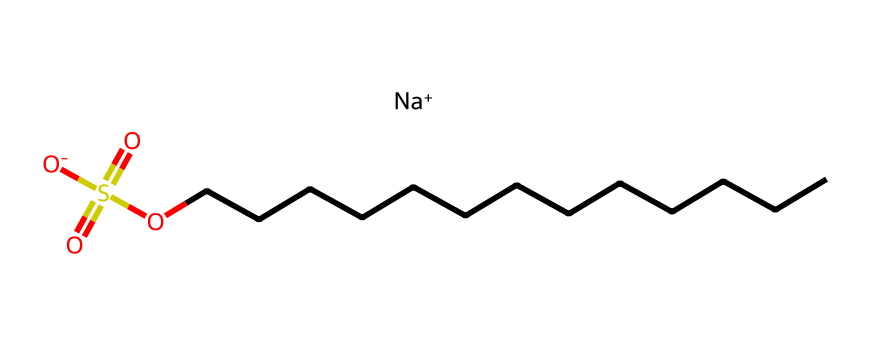How many carbon atoms are in sodium dodecyl sulfate? The chemical structure contains a long hydrocarbon chain indicated by the sequence of "C" in the SMILES representation. Counting the "C" characters, there are 12 carbon atoms in the dodecyl chain.
Answer: 12 What is the primary functional group present in sodium dodecyl sulfate? The chemical includes the sulfonate group (-SO3-), which is a characteristic functional group for the surfactant. This functional group is identified by the sulfur atom bonded to three oxygen atoms in the formula.
Answer: sulfonate What type of surfactant is sodium dodecyl sulfate? The chemical structure displays a negatively charged head group as indicated by the presence of the sulfonate and sodium ion, classifying it as an anionic surfactant.
Answer: anionic What is the molecular charge of sodium dodecyl sulfate? The presence of [Na+] as a positively charged sodium ion and [O-] leading to a net charge indicates that the overall charge of sodium dodecyl sulfate is neutral; however, the head group (sulfonate) has a negative charge.
Answer: neutral What role does the long carbon chain play in sodium dodecyl sulfate? The long hydrocarbon chain improves the hydrophobic characteristics of the molecule, allowing it to interact with oils and dirt during cleaning, enhancing the surfactant's ability to emulsify and solubilize substances in water.
Answer: hydrophobic What does the presence of sodium indicate about the solubility of sodium dodecyl sulfate? The sodium ion contributes to the solubility of the surfactant in water, as it allows the chemical to dissociate in solution and interact with water molecules effectively, facilitating cleaning.
Answer: solubility in water 